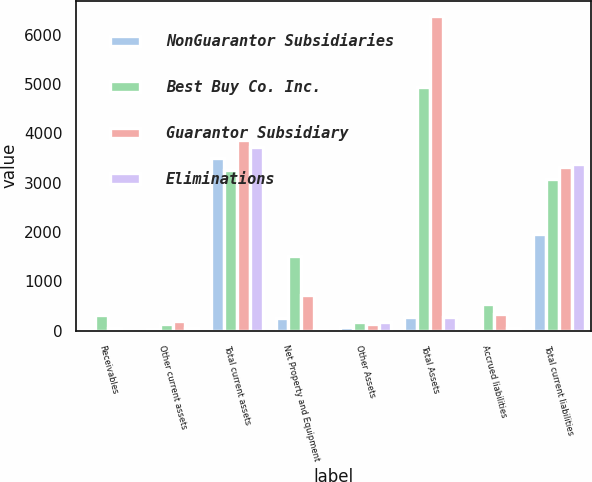<chart> <loc_0><loc_0><loc_500><loc_500><stacked_bar_chart><ecel><fcel>Receivables<fcel>Other current assets<fcel>Total current assets<fcel>Net Property and Equipment<fcel>Other Assets<fcel>Total Assets<fcel>Accrued liabilities<fcel>Total current liabilities<nl><fcel>NonGuarantor Subsidiaries<fcel>12<fcel>34<fcel>3490<fcel>250<fcel>80<fcel>282<fcel>5<fcel>1955<nl><fcel>Best Buy Co. Inc.<fcel>314<fcel>139<fcel>3262<fcel>1504<fcel>171<fcel>4940<fcel>548<fcel>3073<nl><fcel>Guarantor Subsidiary<fcel>48<fcel>200<fcel>3870<fcel>713<fcel>142<fcel>6369<fcel>335<fcel>3314<nl><fcel>Eliminations<fcel>1<fcel>44<fcel>3719<fcel>3<fcel>167<fcel>282<fcel>44<fcel>3383<nl></chart> 